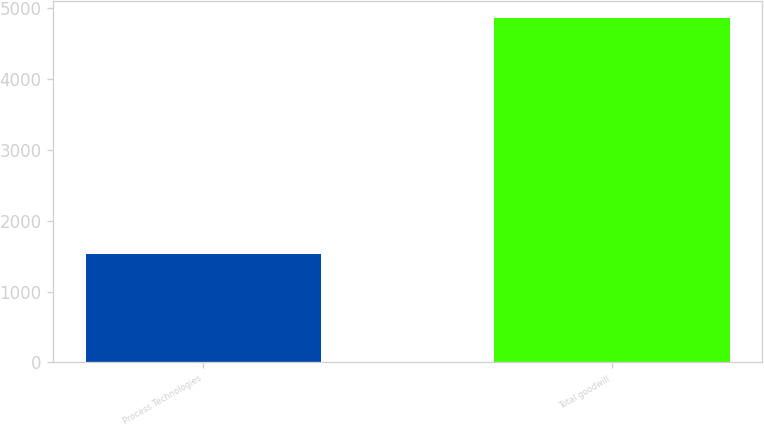Convert chart. <chart><loc_0><loc_0><loc_500><loc_500><bar_chart><fcel>Process Technologies<fcel>Total goodwill<nl><fcel>1524.5<fcel>4860.7<nl></chart> 